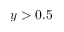Convert formula to latex. <formula><loc_0><loc_0><loc_500><loc_500>y > 0 . 5</formula> 